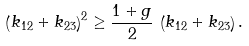Convert formula to latex. <formula><loc_0><loc_0><loc_500><loc_500>\left ( k _ { 1 2 } + k _ { 2 3 } \right ) ^ { 2 } \geq \frac { 1 + g } { 2 } \, \left ( k _ { 1 2 } + k _ { 2 3 } \right ) .</formula> 